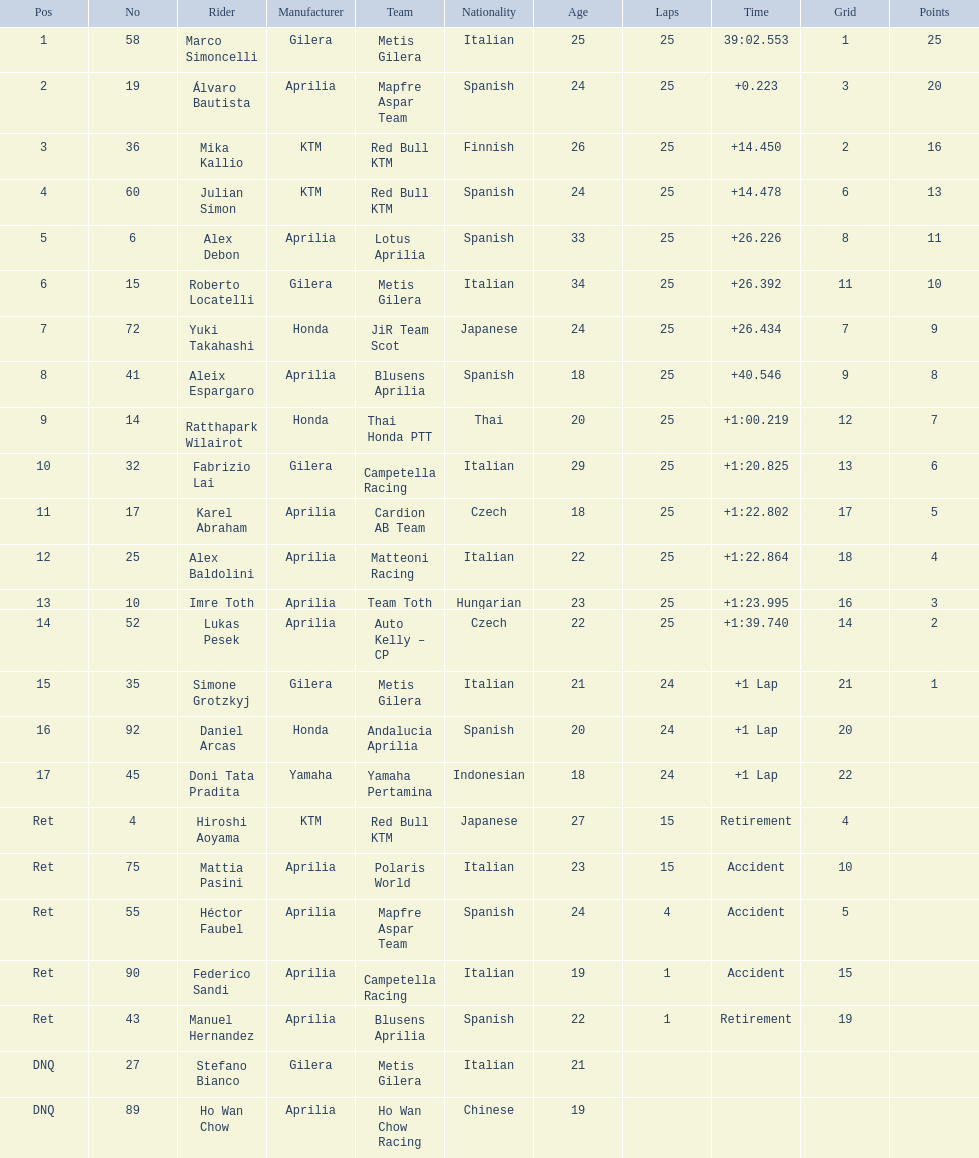What was the fastest overall time? 39:02.553. Who does this time belong to? Marco Simoncelli. 